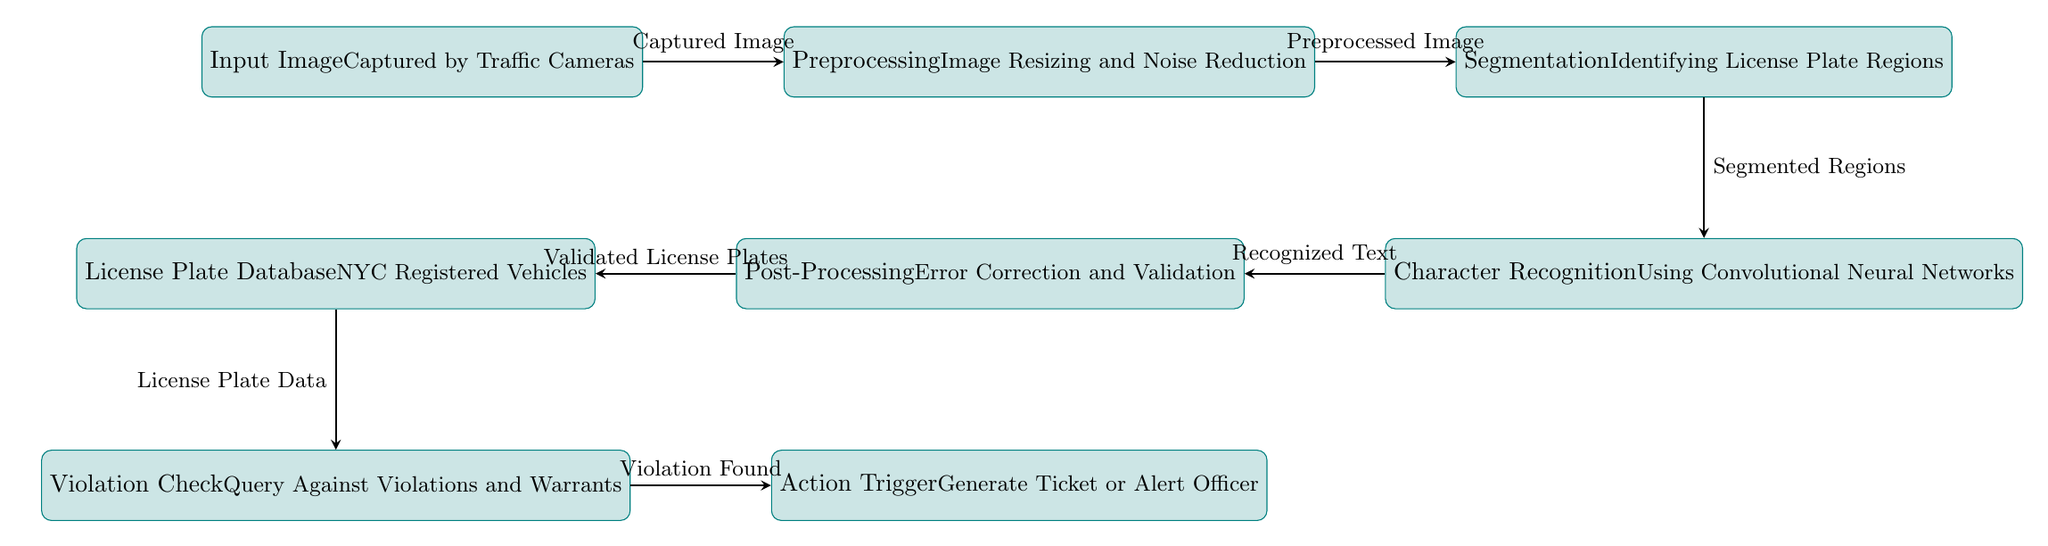What is the first step in the process? The first node in the diagram is labeled "Input Image" and mentions that the image is captured by traffic cameras, indicating this is the initial step to start the process of automatic license plate recognition.
Answer: Input Image How many processes are represented in the diagram? By counting the nodes labeled as processes in the diagram, we find a total of 8 distinct processes, from the input image to the action trigger.
Answer: 8 What does the segmentation process identify? The node labeled "Segmentation" specifies that it is responsible for identifying license plate regions, which indicates the specific focus of this step in the process.
Answer: License Plate Regions Which process follows post-processing? Between the "Post-Processing" node and the "Action Trigger" node, the diagram clearly shows that "License Plate Database" follows post-processing, depicting the order of the processes in the flow.
Answer: License Plate Database What is checked against violations and warrants? The "Violation Check" node in the diagram indicates it queries against violations and warrants, which means it is validating the recognized license plate information against recorded data.
Answer: Recognized License Plates What type of network is used for character recognition? The process labeled "Character Recognition" explicitly mentions that it uses "Convolutional Neural Networks," which is a specific type of deep learning model commonly utilized for image processing tasks.
Answer: Convolutional Neural Networks What action is triggered if a violation is found? The "Action Trigger" node states that it generates a ticket or alerts the officer, detailing the actions taken as a response to the violation found.
Answer: Generate Ticket or Alert Officer What data is utilized in the license plate database? The "License Plate Database" node specifies that it consists of data related to NYC registered vehicles, which indicates the source of information used for comparison during the detection process.
Answer: NYC Registered Vehicles 